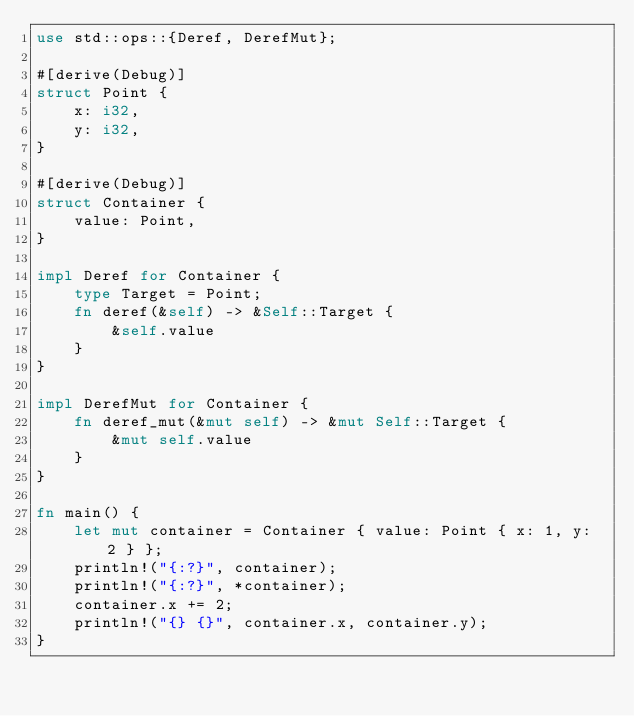Convert code to text. <code><loc_0><loc_0><loc_500><loc_500><_Rust_>use std::ops::{Deref, DerefMut};

#[derive(Debug)]
struct Point {
    x: i32,
    y: i32,
}

#[derive(Debug)]
struct Container {
    value: Point,
}

impl Deref for Container {
    type Target = Point;
    fn deref(&self) -> &Self::Target {
        &self.value
    }
}

impl DerefMut for Container {
    fn deref_mut(&mut self) -> &mut Self::Target {
        &mut self.value
    }
}

fn main() {
    let mut container = Container { value: Point { x: 1, y: 2 } };
    println!("{:?}", container);
    println!("{:?}", *container);
    container.x += 2;
    println!("{} {}", container.x, container.y);
}
</code> 